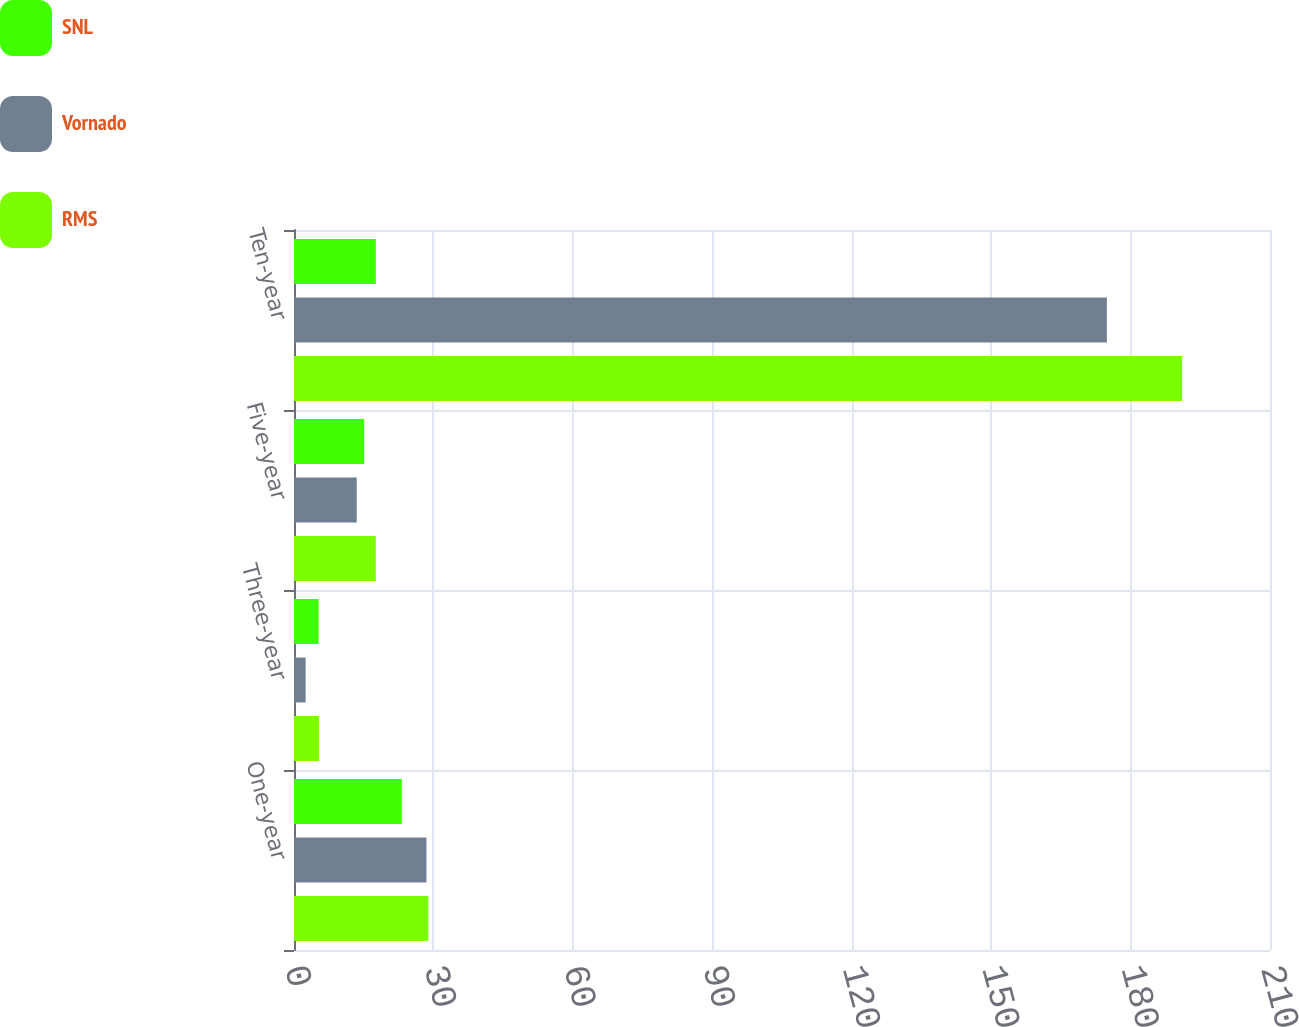Convert chart to OTSL. <chart><loc_0><loc_0><loc_500><loc_500><stacked_bar_chart><ecel><fcel>One-year<fcel>Three-year<fcel>Five-year<fcel>Ten-year<nl><fcel>SNL<fcel>23.2<fcel>5.3<fcel>15.1<fcel>17.6<nl><fcel>Vornado<fcel>28.5<fcel>2.5<fcel>13.5<fcel>174.9<nl><fcel>RMS<fcel>28.9<fcel>5.4<fcel>17.6<fcel>191.1<nl></chart> 